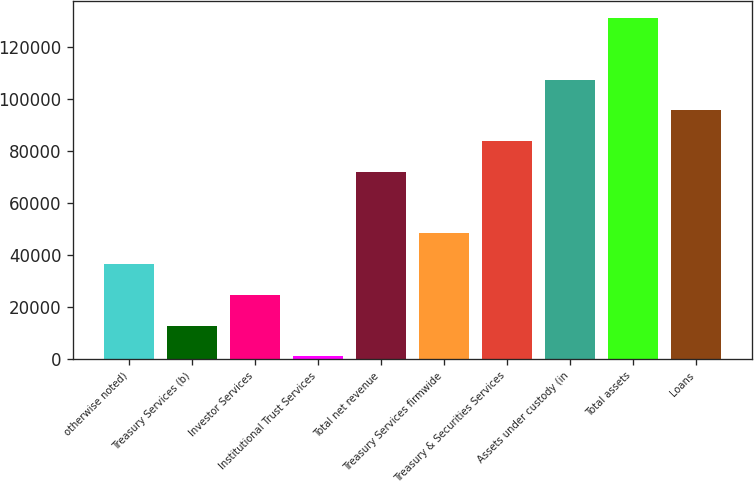<chart> <loc_0><loc_0><loc_500><loc_500><bar_chart><fcel>otherwise noted)<fcel>Treasury Services (b)<fcel>Investor Services<fcel>Institutional Trust Services<fcel>Total net revenue<fcel>Treasury Services firmwide<fcel>Treasury & Securities Services<fcel>Assets under custody (in<fcel>Total assets<fcel>Loans<nl><fcel>36445.5<fcel>12788.5<fcel>24617<fcel>960<fcel>71931<fcel>48274<fcel>83759.5<fcel>107416<fcel>131074<fcel>95588<nl></chart> 